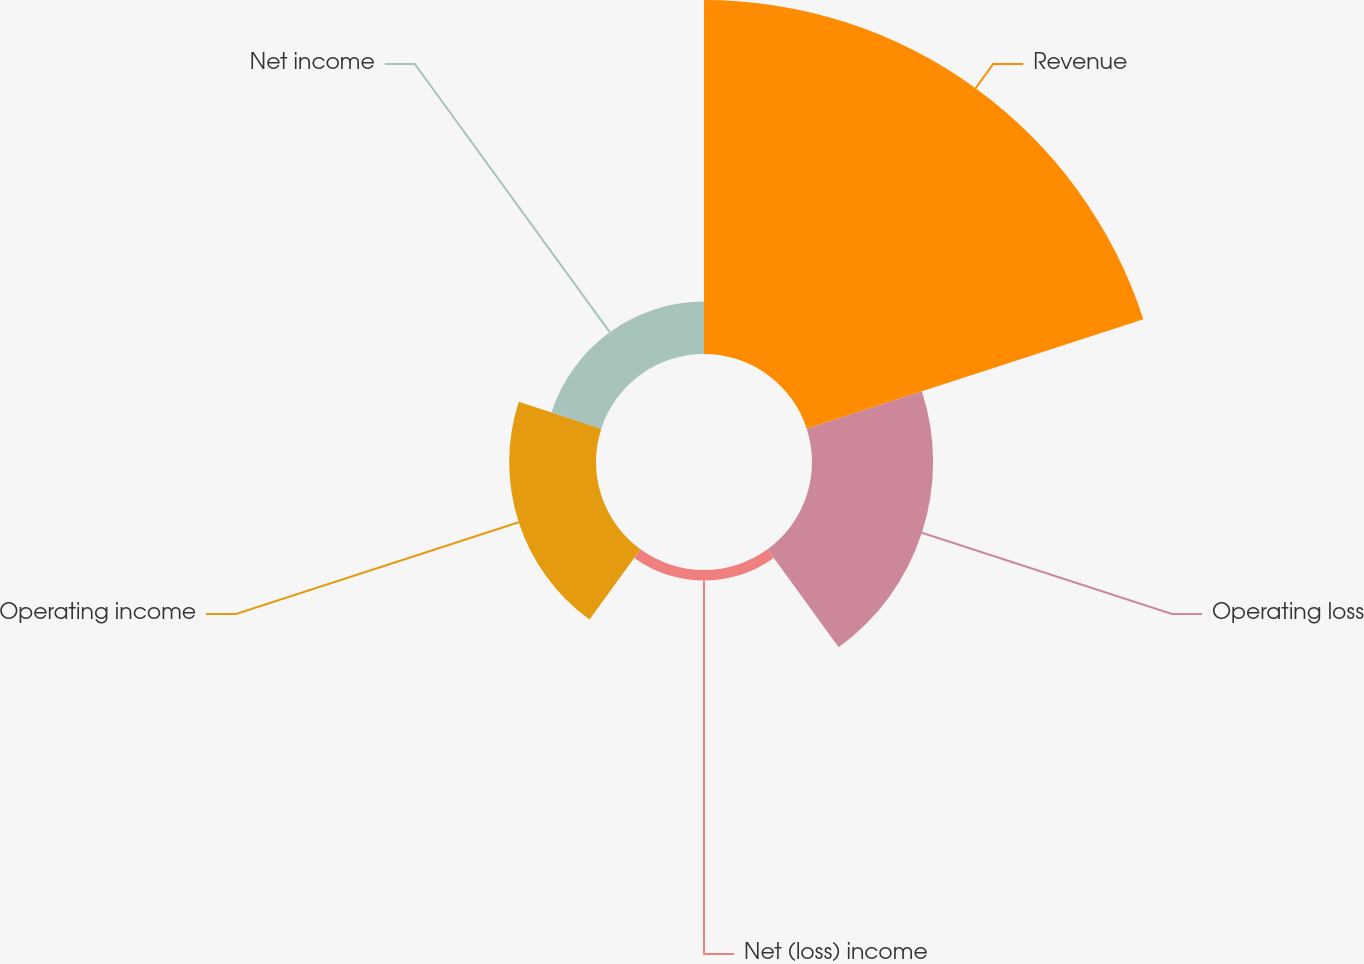Convert chart. <chart><loc_0><loc_0><loc_500><loc_500><pie_chart><fcel>Revenue<fcel>Operating loss<fcel>Net (loss) income<fcel>Operating income<fcel>Net income<nl><fcel>56.65%<fcel>19.38%<fcel>1.69%<fcel>13.89%<fcel>8.39%<nl></chart> 